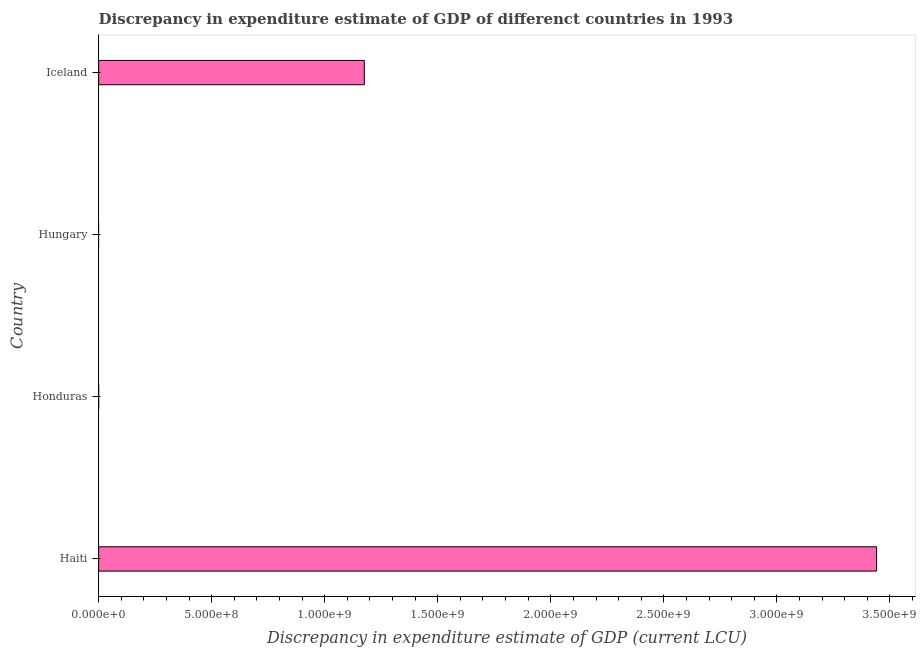Does the graph contain any zero values?
Give a very brief answer. Yes. Does the graph contain grids?
Ensure brevity in your answer.  No. What is the title of the graph?
Offer a very short reply. Discrepancy in expenditure estimate of GDP of differenct countries in 1993. What is the label or title of the X-axis?
Keep it short and to the point. Discrepancy in expenditure estimate of GDP (current LCU). What is the discrepancy in expenditure estimate of gdp in Haiti?
Keep it short and to the point. 3.44e+09. Across all countries, what is the maximum discrepancy in expenditure estimate of gdp?
Give a very brief answer. 3.44e+09. Across all countries, what is the minimum discrepancy in expenditure estimate of gdp?
Your answer should be very brief. 0. In which country was the discrepancy in expenditure estimate of gdp maximum?
Offer a very short reply. Haiti. What is the sum of the discrepancy in expenditure estimate of gdp?
Keep it short and to the point. 4.62e+09. What is the difference between the discrepancy in expenditure estimate of gdp in Haiti and Honduras?
Your answer should be compact. 3.44e+09. What is the average discrepancy in expenditure estimate of gdp per country?
Provide a succinct answer. 1.15e+09. What is the median discrepancy in expenditure estimate of gdp?
Your answer should be very brief. 5.88e+08. What is the ratio of the discrepancy in expenditure estimate of gdp in Haiti to that in Honduras?
Provide a succinct answer. 1.72e+15. Is the discrepancy in expenditure estimate of gdp in Haiti less than that in Iceland?
Offer a terse response. No. Is the difference between the discrepancy in expenditure estimate of gdp in Haiti and Honduras greater than the difference between any two countries?
Your answer should be very brief. No. What is the difference between the highest and the second highest discrepancy in expenditure estimate of gdp?
Offer a very short reply. 2.27e+09. Is the sum of the discrepancy in expenditure estimate of gdp in Honduras and Iceland greater than the maximum discrepancy in expenditure estimate of gdp across all countries?
Ensure brevity in your answer.  No. What is the difference between the highest and the lowest discrepancy in expenditure estimate of gdp?
Provide a succinct answer. 3.44e+09. In how many countries, is the discrepancy in expenditure estimate of gdp greater than the average discrepancy in expenditure estimate of gdp taken over all countries?
Provide a succinct answer. 2. How many bars are there?
Ensure brevity in your answer.  3. What is the difference between two consecutive major ticks on the X-axis?
Make the answer very short. 5.00e+08. What is the Discrepancy in expenditure estimate of GDP (current LCU) in Haiti?
Ensure brevity in your answer.  3.44e+09. What is the Discrepancy in expenditure estimate of GDP (current LCU) of Honduras?
Your answer should be compact. 2e-6. What is the Discrepancy in expenditure estimate of GDP (current LCU) of Hungary?
Your response must be concise. 0. What is the Discrepancy in expenditure estimate of GDP (current LCU) of Iceland?
Your answer should be very brief. 1.18e+09. What is the difference between the Discrepancy in expenditure estimate of GDP (current LCU) in Haiti and Honduras?
Ensure brevity in your answer.  3.44e+09. What is the difference between the Discrepancy in expenditure estimate of GDP (current LCU) in Haiti and Iceland?
Your response must be concise. 2.27e+09. What is the difference between the Discrepancy in expenditure estimate of GDP (current LCU) in Honduras and Iceland?
Your response must be concise. -1.18e+09. What is the ratio of the Discrepancy in expenditure estimate of GDP (current LCU) in Haiti to that in Honduras?
Offer a terse response. 1.72e+15. What is the ratio of the Discrepancy in expenditure estimate of GDP (current LCU) in Haiti to that in Iceland?
Make the answer very short. 2.93. 